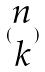<formula> <loc_0><loc_0><loc_500><loc_500>( \begin{matrix} n \\ k \end{matrix} )</formula> 